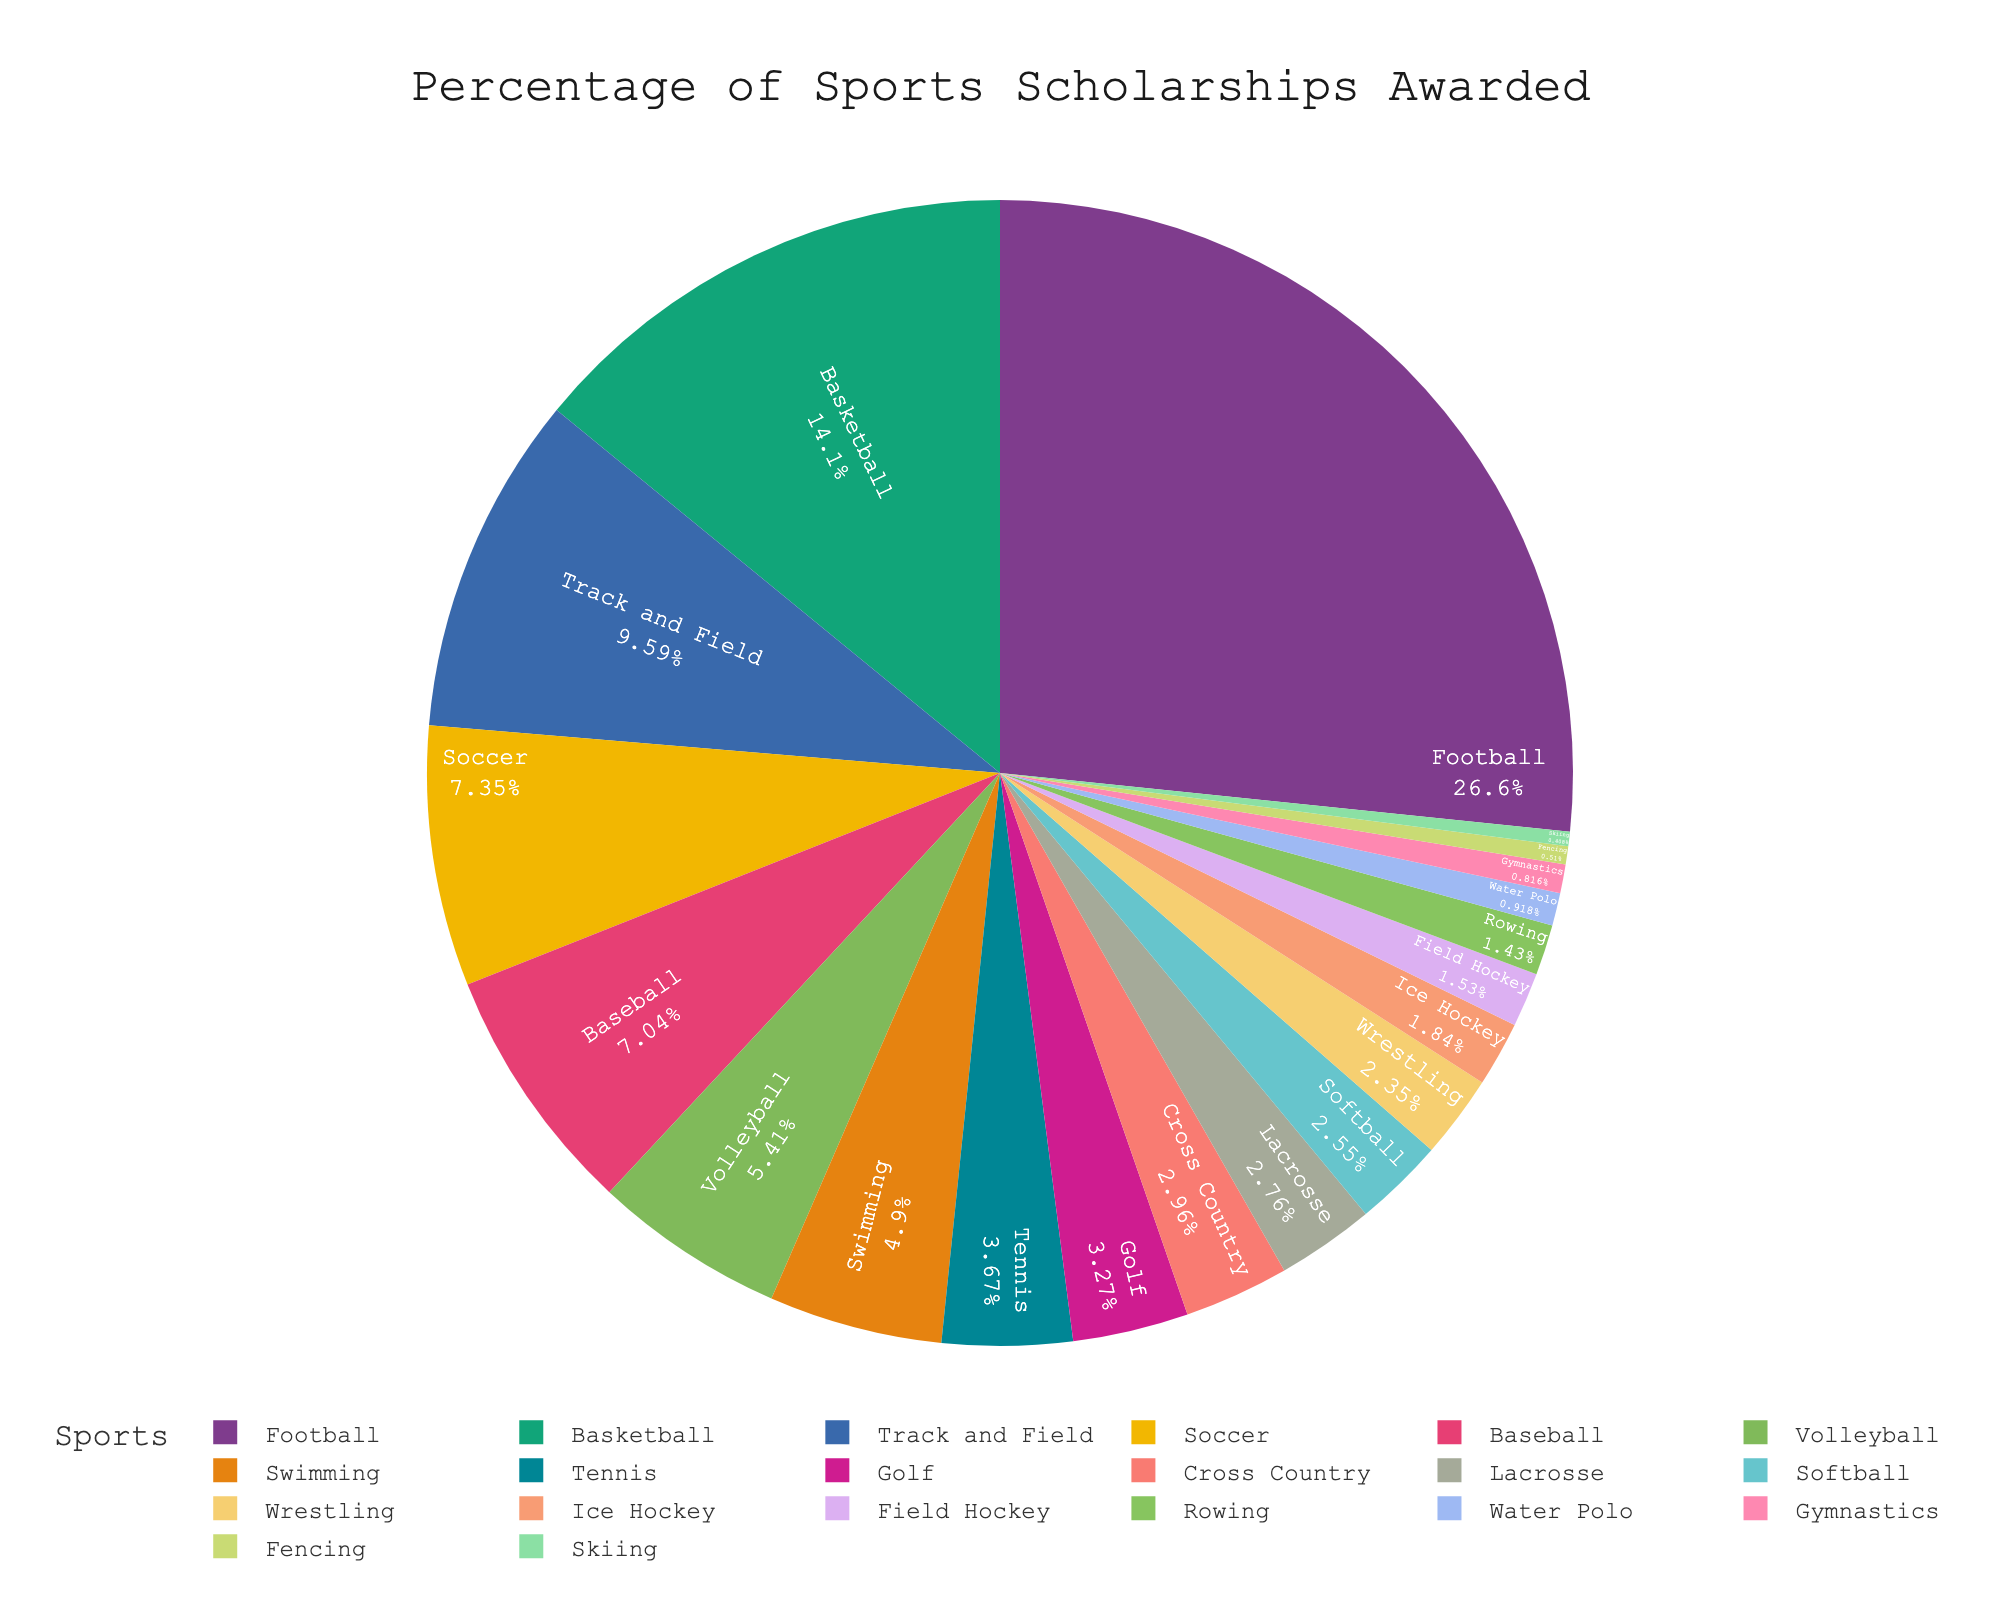Which sport awards the highest percentage of scholarships? The sport with the largest section of the pie chart is football, which means it awards the highest percentage of scholarships.
Answer: Football Which two sports combined have a scholarship percentage closest to 10%? Tennis and Golf have percentages of 3.6% and 3.2% respectively. Adding these gives 6.8%. Volleyball and Swimming have percentages of 5.3% and 4.8% respectively, adding to 10.1% which is closer to 10%.
Answer: Volleyball and Swimming Is the percentage of scholarships awarded for Baseball greater than that for Volleyball? The pie chart shows that Baseball awards 6.9% of scholarships while Volleyball awards 5.3%. Since 6.9% is greater than 5.3%, Baseball awards a higher percentage.
Answer: Yes What is the total percentage of scholarships awarded by the three least represented sports? The three sports with the smallest sections are Skiing (0.4%), Fencing (0.5%), and Gymnastics (0.8%). Adding these gives 0.4 + 0.5 + 0.8 = 1.7%.
Answer: 1.7% Which category represents a larger share of scholarships, Swimming or Soccer? From the pie chart, Swimming awards 4.8% and Soccer awards 7.2%, so Soccer has a larger share.
Answer: Soccer How much more is the percentage of scholarships awarded for Football compared to Ice Hockey? Football awards 26.1%, and Ice Hockey awards 1.8%. The difference is 26.1 - 1.8 = 24.3%.
Answer: 24.3% What is the average percentage of scholarships for Track and Field, Soccer, and Baseball? Summing the percentages: Track and Field (9.4%), Soccer (7.2%), and Baseball (6.9%) gives 9.4 + 7.2 + 6.9 = 23.5. The average is 23.5 / 3 = 7.83%.
Answer: 7.83% If Field Hockey and Rowing are combined into one category, how does this new category compare to the percentage for Lacrosse? Field Hockey is 1.5% and Rowing is 1.4%. Combined they are 1.5 + 1.4 = 2.9%. Lacrosse alone is 2.7%, so the new combined category is slightly higher than Lacrosse.
Answer: Higher List the sports that have a scholarship percentage less than 1%. From the pie chart, sports with less than 1% are Water Polo (0.9%), Gymnastics (0.8%), Fencing (0.5%), and Skiing (0.4%).
Answer: Water Polo, Gymnastics, Fencing, Skiing 